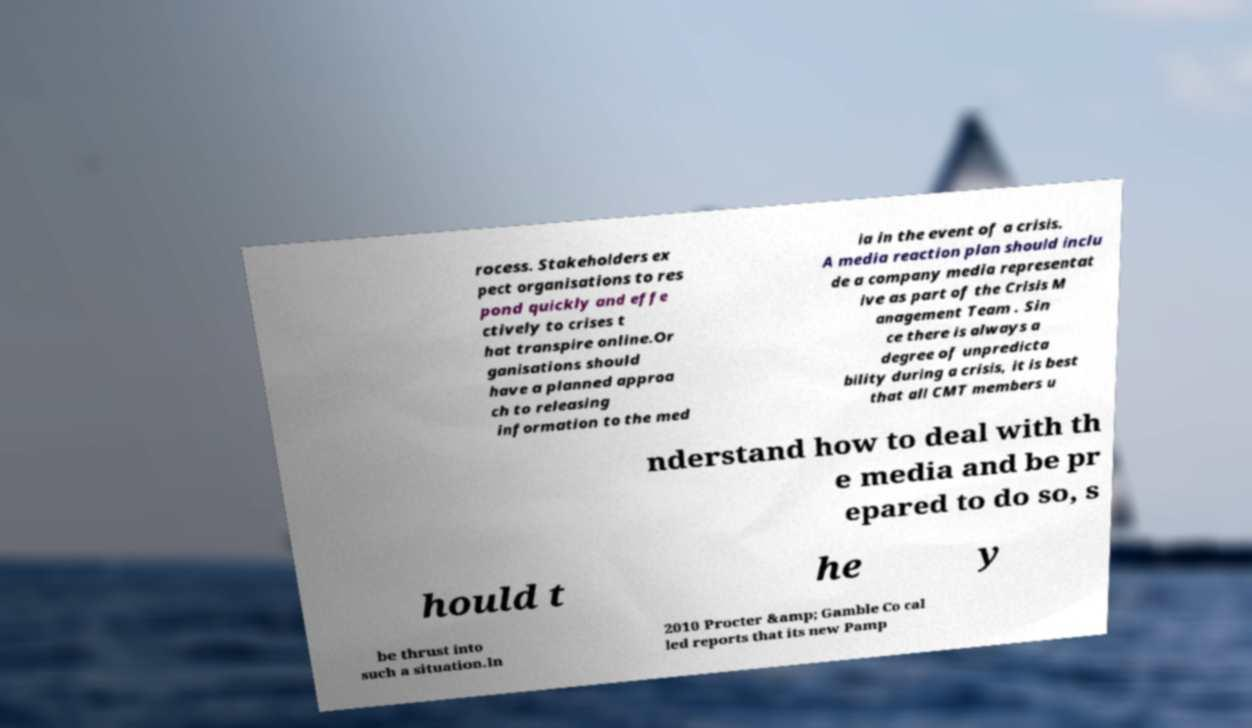I need the written content from this picture converted into text. Can you do that? rocess. Stakeholders ex pect organisations to res pond quickly and effe ctively to crises t hat transpire online.Or ganisations should have a planned approa ch to releasing information to the med ia in the event of a crisis. A media reaction plan should inclu de a company media representat ive as part of the Crisis M anagement Team . Sin ce there is always a degree of unpredicta bility during a crisis, it is best that all CMT members u nderstand how to deal with th e media and be pr epared to do so, s hould t he y be thrust into such a situation.In 2010 Procter &amp; Gamble Co cal led reports that its new Pamp 